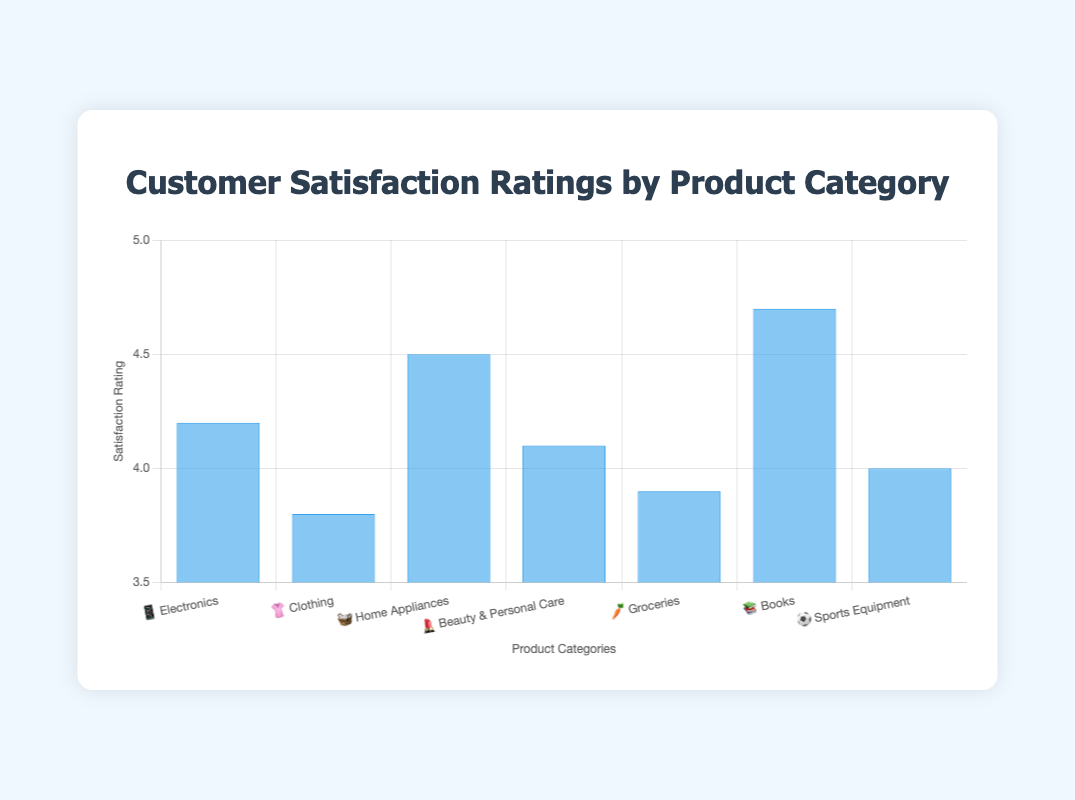What's the highest customer satisfaction rating? By looking at the bar heights, the category with the highest satisfaction rating is identified. Books have the highest rating of 4.7.
Answer: 4.7 Which product category has the lowest customer satisfaction? The category with the shortest bar represents the lowest satisfaction rating. Clothing has a rating of 3.8.
Answer: Clothing How many product categories have a satisfaction rating above 4.0? Count the number of bars that are above the 4.0 mark on the y-axis. There are five categories: Electronics, Home Appliances, Beauty & Personal Care, Books, and Sports Equipment.
Answer: 5 What's the difference in satisfaction ratings between Electronics and Groceries? Subtract the satisfaction rating of Groceries from that of Electronics. 4.2 (Electronics) - 3.9 (Groceries) = 0.3
Answer: 0.3 Which category shows a satisfaction rating of exactly 4.0? By checking the heights of the bars, Sports Equipment has a satisfaction rating of 4.0.
Answer: Sports Equipment Arrange the product categories in descending order of customer satisfaction. List the categories based on the height of their bars from highest to lowest. Books ➡ Home Appliances ➡ Electronics ➡ Beauty & Personal Care ➡ Sports Equipment ➡ Groceries ➡ Clothing.
Answer: Books, Home Appliances, Electronics, Beauty & Personal Care, Sports Equipment, Groceries, Clothing What is the average satisfaction rating across all product categories? Add the satisfaction ratings of all categories and divide by the number of categories. (4.2 + 3.8 + 4.5 + 4.1 + 3.9 + 4.7 + 4.0) / 7 ≈ 4.17
Answer: 4.17 Which category with an emoji 📚 has the highest rating? Identify the category with the 📚 emoji and note its rating. Books, which has a rating of 4.7.
Answer: Books What is the satisfaction range covered by the categories? Subtract the lowest rating from the highest rating. 4.7 (highest, Books) - 3.8 (lowest, Clothing) = 0.9
Answer: 0.9 